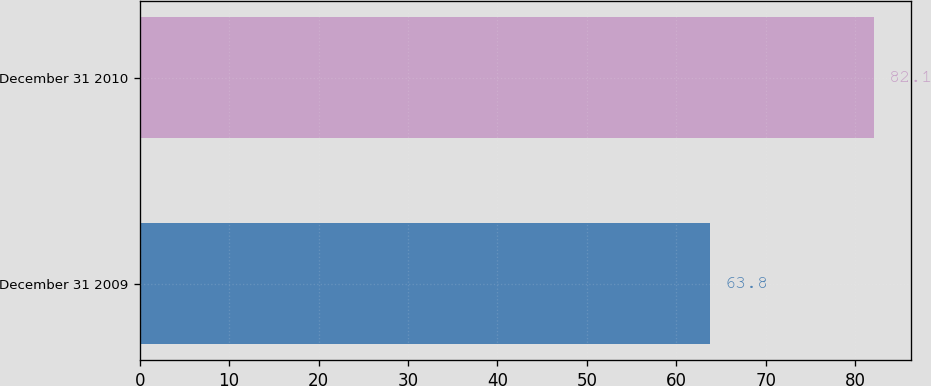Convert chart. <chart><loc_0><loc_0><loc_500><loc_500><bar_chart><fcel>December 31 2009<fcel>December 31 2010<nl><fcel>63.8<fcel>82.1<nl></chart> 